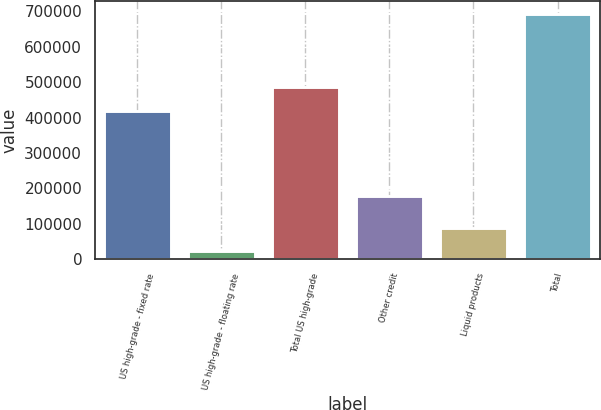Convert chart. <chart><loc_0><loc_0><loc_500><loc_500><bar_chart><fcel>US high-grade - fixed rate<fcel>US high-grade - floating rate<fcel>Total US high-grade<fcel>Other credit<fcel>Liquid products<fcel>Total<nl><fcel>418270<fcel>21813<fcel>485456<fcel>177274<fcel>88999.3<fcel>693676<nl></chart> 